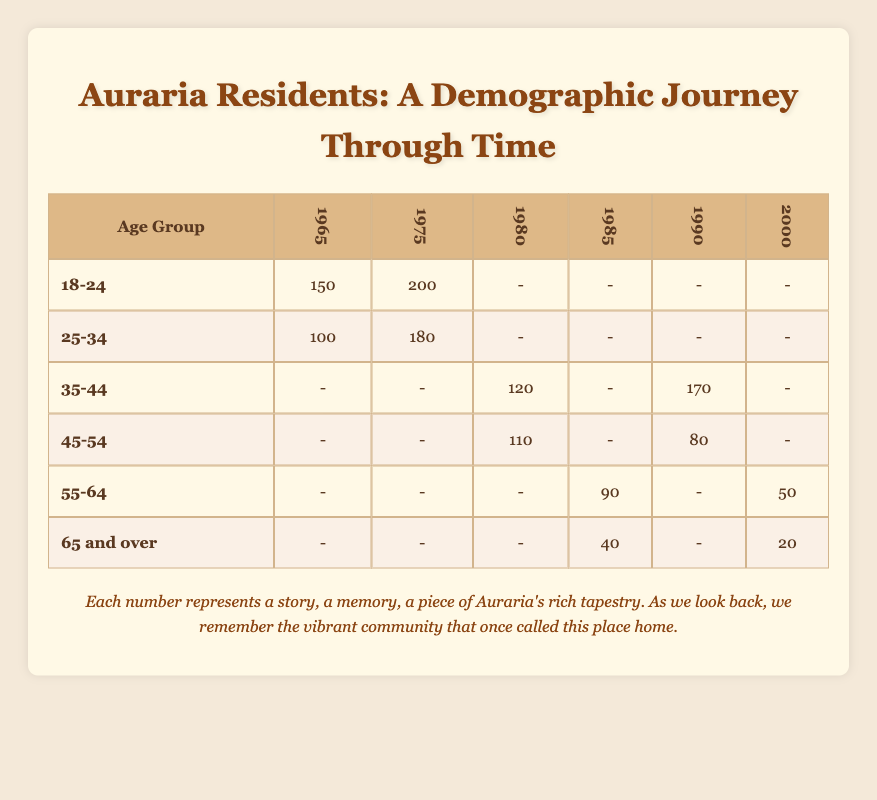What was the total number of 18-24 year-olds that left in 1975? The table shows that the count for the age group 18-24 in the year 1975 is 200.
Answer: 200 How many residents aged 25-34 left in total from 1965 and 1975? To find the total, we add the counts for age group 25-34 for the years 1965 (100) and 1975 (180). The total is 100 + 180 = 280.
Answer: 280 Was there any resident aged 65 and over who left in 1965? Based on the table, there are no entries for the age group 65 and over for the year 1965, indicating that no such residents left that year.
Answer: No What is the average number of 55-64 year-olds that departed in 1985 and 2000? To find the average, we need to examine the counts of 55-64 year-olds for the years 1985 (90) and 2000 (50). The total is 90 + 50 = 140, and the average is 140 divided by 2, which equals 70.
Answer: 70 Which age group had the highest count of residents leaving in 1990? From the table, the age group 35-44 shows the highest count of 170 for the year 1990, compared to other groups.
Answer: 35-44 How many residents aged 45-54 left between 1980 and 1990? For the age group 45-54, the counts are 110 for 1980 and 80 for 1990. Adding these gives 110 + 80 = 190.
Answer: 190 Were there more residents aged 18-24 in 1975 than those aged 25-34 in the same year? The table shows 200 residents aged 18-24 in 1975 and 180 aged 25-34 in the same year. Since 200 is greater than 180, the answer is yes.
Answer: Yes What is the difference in departure counts between residents aged 35-44 who left in 1990 and those aged 45-54 who left in 1980? The age group 35-44 had 170 residents leave in 1990, while the age group 45-54 had 110 leave in 1980. The difference is 170 - 110 = 60.
Answer: 60 Which year had the least number of departures among the age group 55-64? The counts for age group 55-64 show 90 for 1985 and 50 for 2000. The least count is 50 in the year 2000.
Answer: 2000 